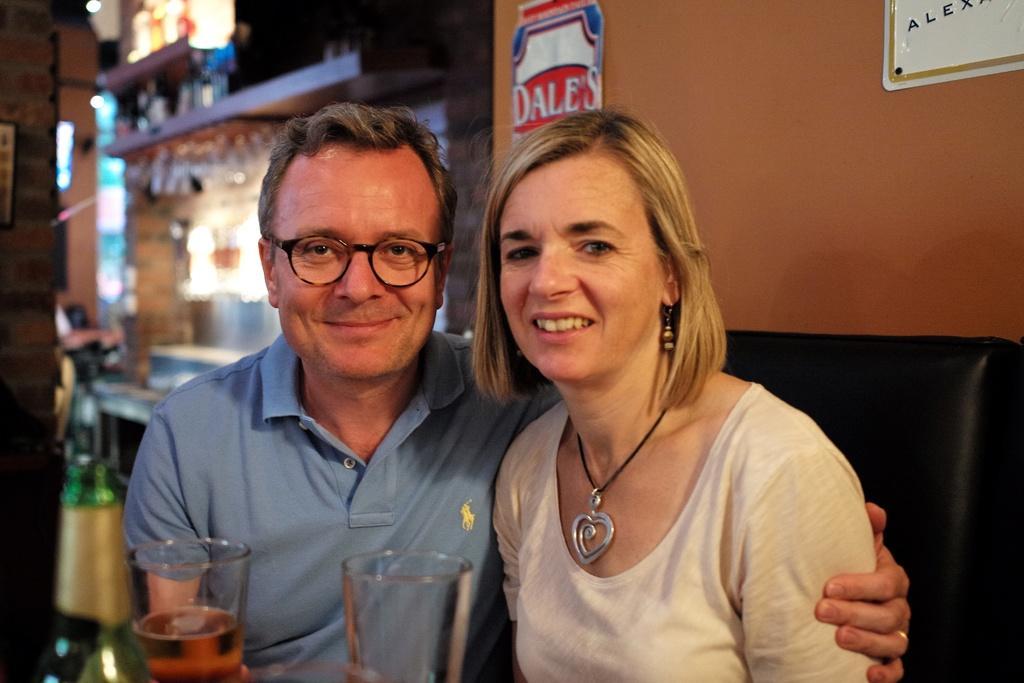In one or two sentences, can you explain what this image depicts? This man and woman are smiling. This man wore spectacles. In-front of them there is a bottle and glasses. Background it is blurry and we can see the lights. Boards are on the wall.  